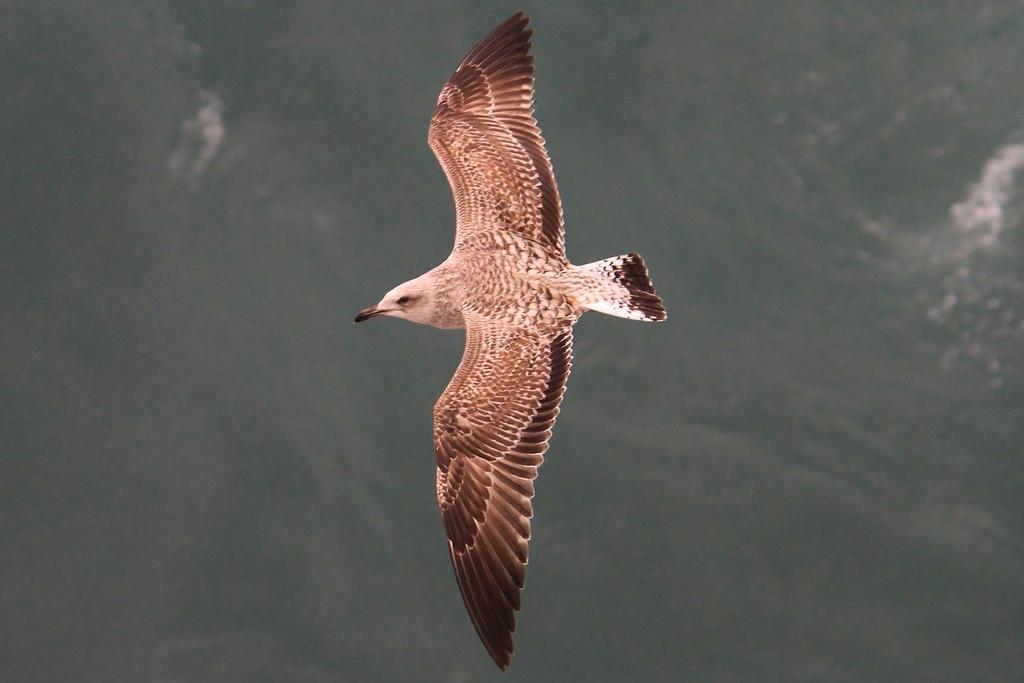What type of animal can be seen in the image? There is a bird in the image. What is the bird doing in the image? The bird is flying in the sky. What type of receipt is the bird holding in its beak in the image? There is no receipt present in the image; it features a bird flying in the sky. What is the title of the baseball game that the bird is attending in the image? There is no baseball game or title mentioned in the image; it only shows a bird flying in the sky. 